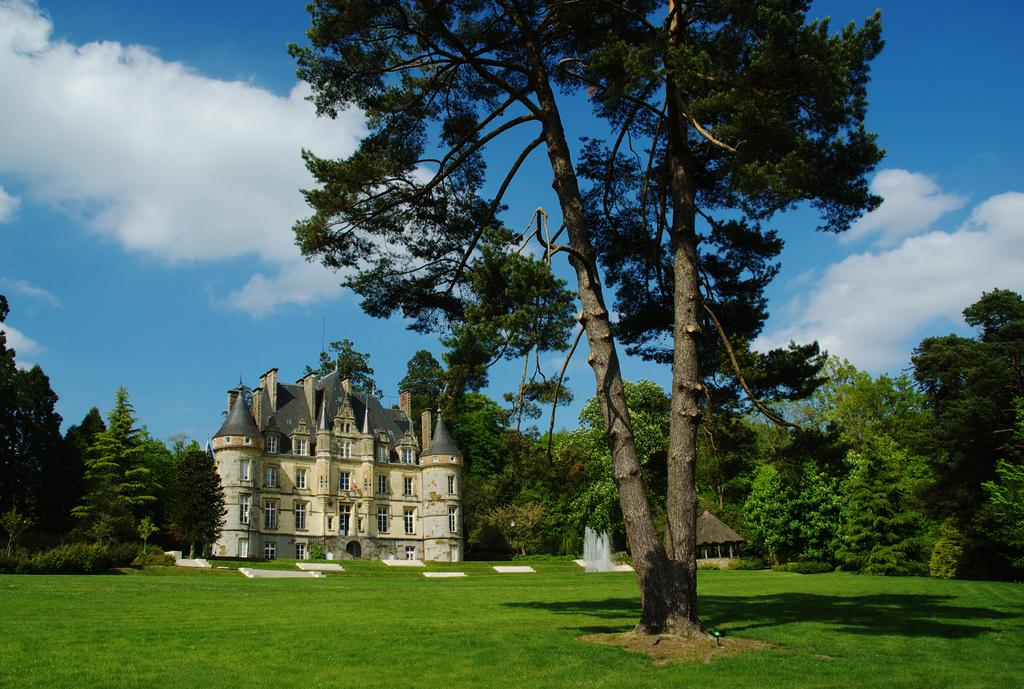What type of natural elements can be seen in the image? There are trees visible in the image. What type of man-made structure can be seen in the background of the image? There is a building in the background of the image. What type of landscape feature is visible in the image? There is water visible in the image. How many history books does the woman in the image have on her beginner's shelf? There is no woman or history books present in the image. 